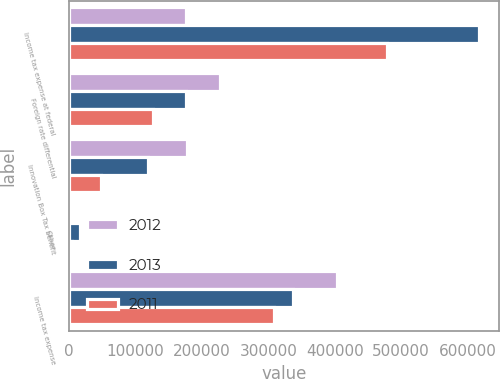Convert chart to OTSL. <chart><loc_0><loc_0><loc_500><loc_500><stacked_bar_chart><ecel><fcel>Income tax expense at federal<fcel>Foreign rate differential<fcel>Innovation Box Tax benefit<fcel>Other<fcel>Income tax expense<nl><fcel>2012<fcel>176564<fcel>226894<fcel>177195<fcel>4040<fcel>403739<nl><fcel>2013<fcel>616654<fcel>175932<fcel>118916<fcel>16026<fcel>337832<nl><fcel>2011<fcel>478728<fcel>125824<fcel>48101<fcel>3860<fcel>308663<nl></chart> 